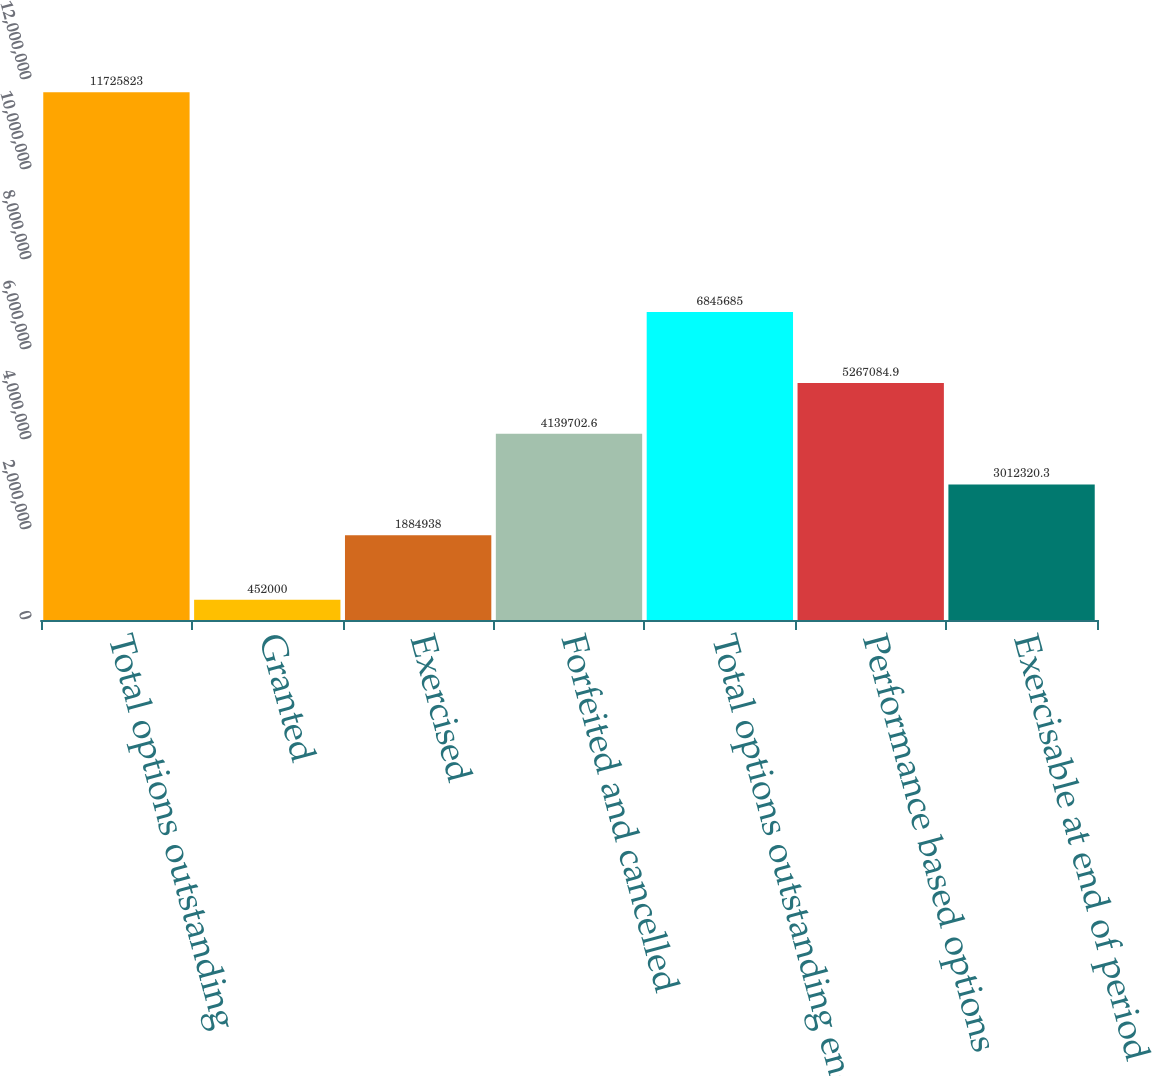Convert chart to OTSL. <chart><loc_0><loc_0><loc_500><loc_500><bar_chart><fcel>Total options outstanding<fcel>Granted<fcel>Exercised<fcel>Forfeited and cancelled<fcel>Total options outstanding end<fcel>Performance based options<fcel>Exercisable at end of period<nl><fcel>1.17258e+07<fcel>452000<fcel>1.88494e+06<fcel>4.1397e+06<fcel>6.84568e+06<fcel>5.26708e+06<fcel>3.01232e+06<nl></chart> 